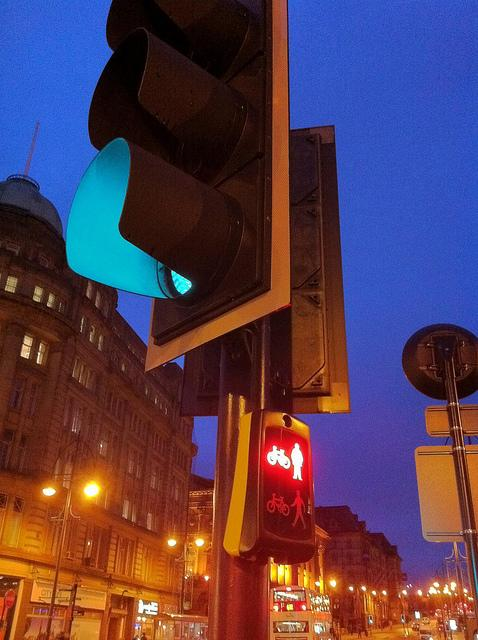What does the bottom red light prohibit? crossing 